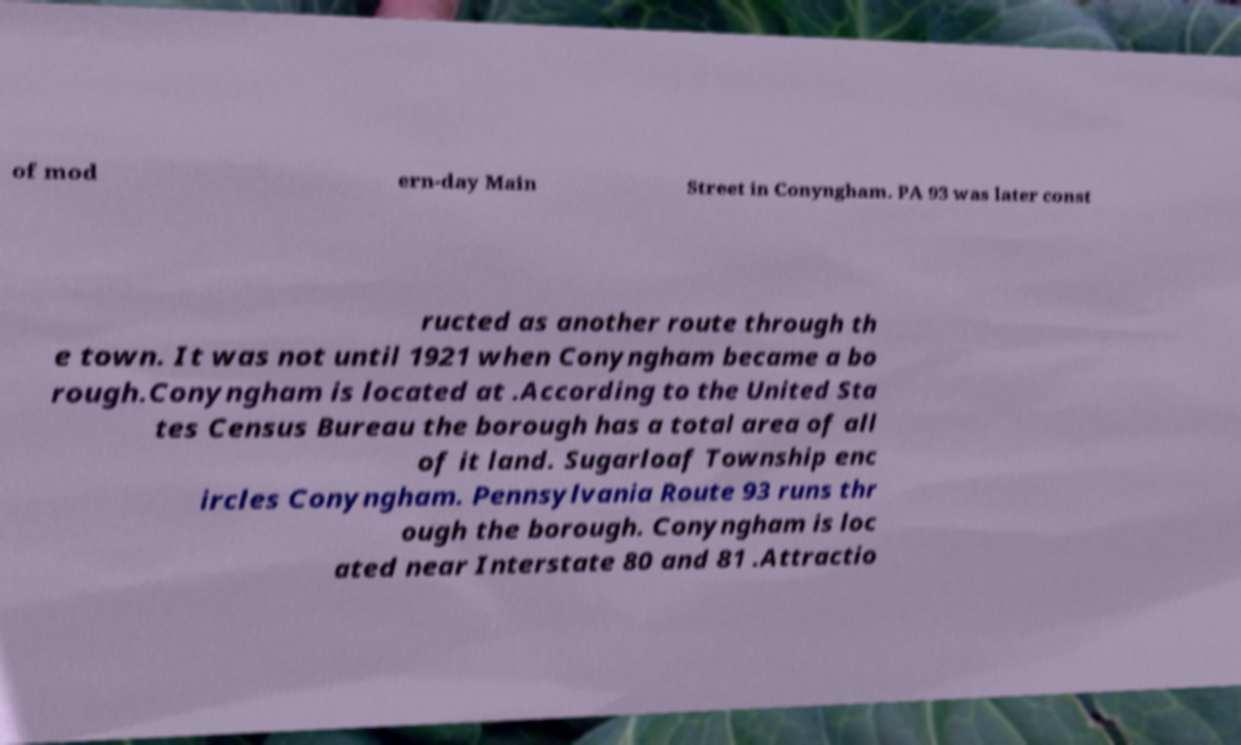I need the written content from this picture converted into text. Can you do that? of mod ern-day Main Street in Conyngham. PA 93 was later const ructed as another route through th e town. It was not until 1921 when Conyngham became a bo rough.Conyngham is located at .According to the United Sta tes Census Bureau the borough has a total area of all of it land. Sugarloaf Township enc ircles Conyngham. Pennsylvania Route 93 runs thr ough the borough. Conyngham is loc ated near Interstate 80 and 81 .Attractio 